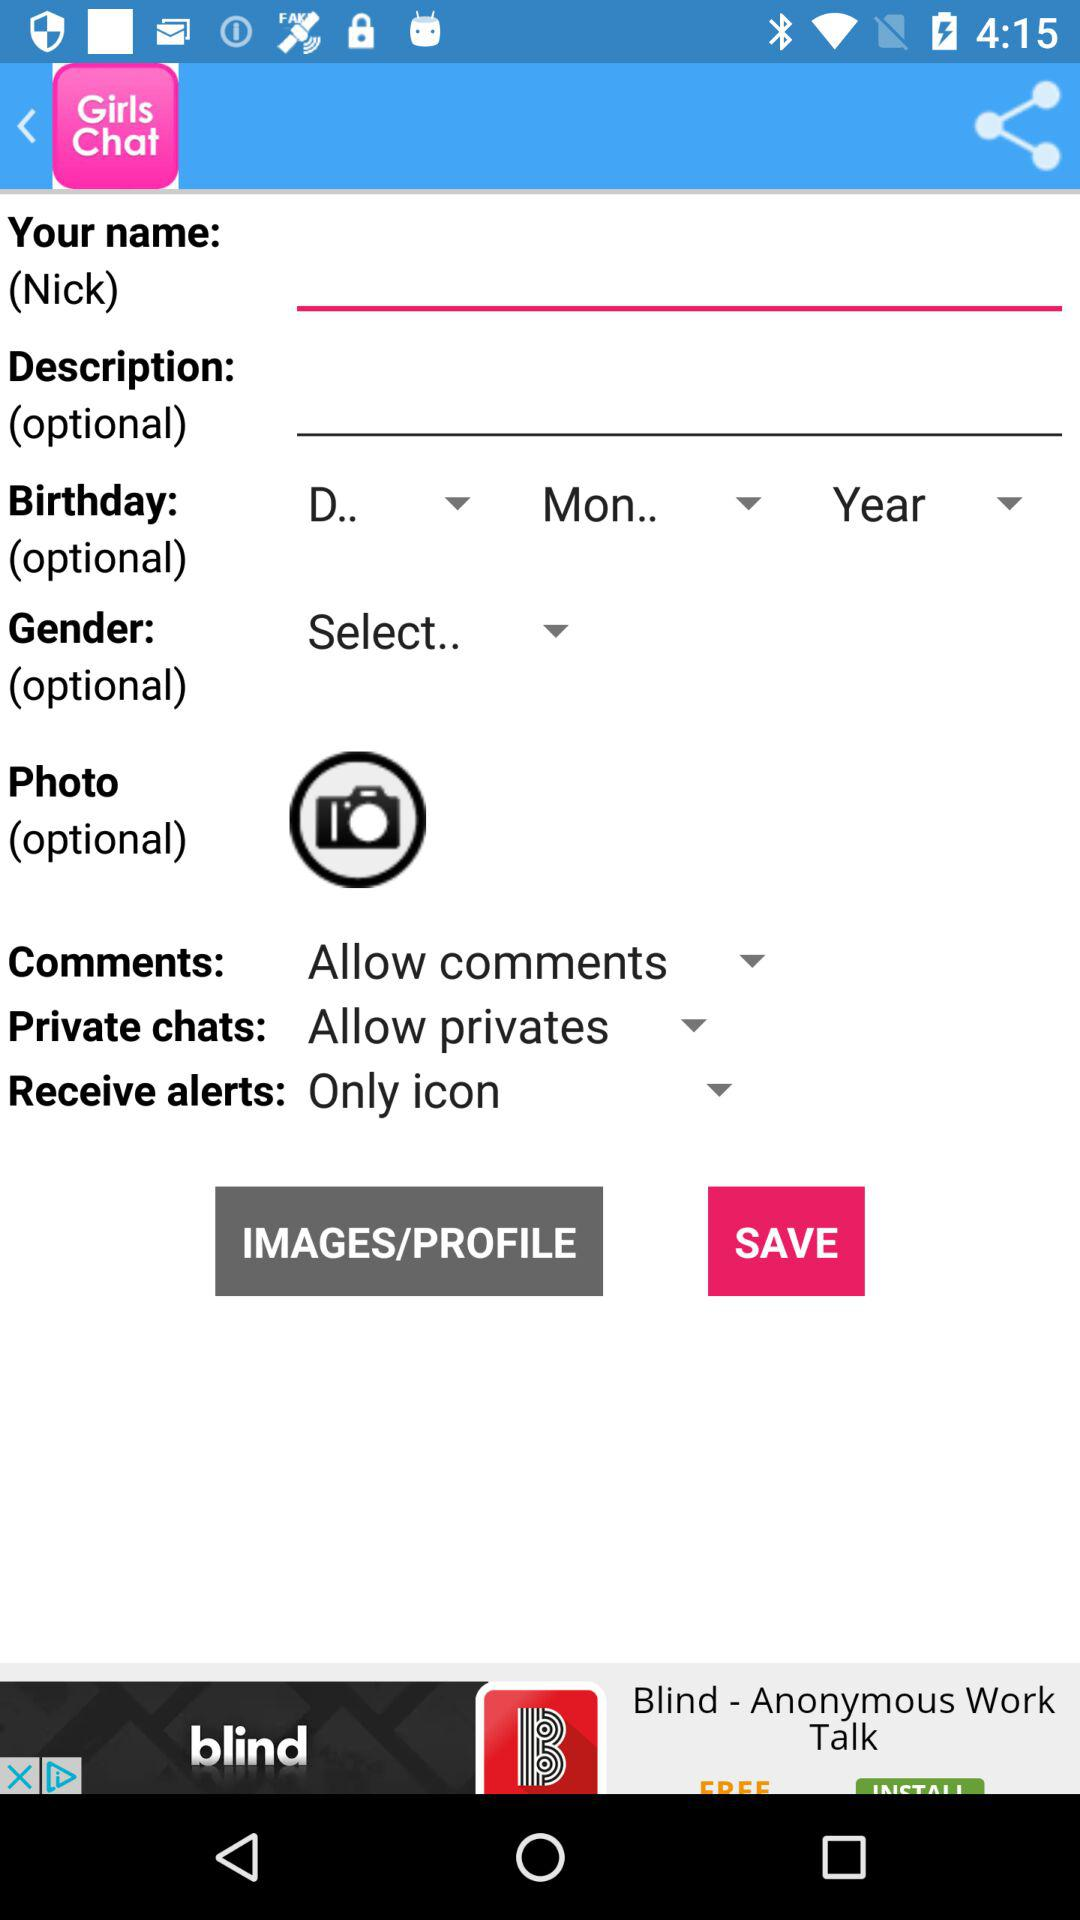What is the name of the application? The name of the application is "Girls Chat". 